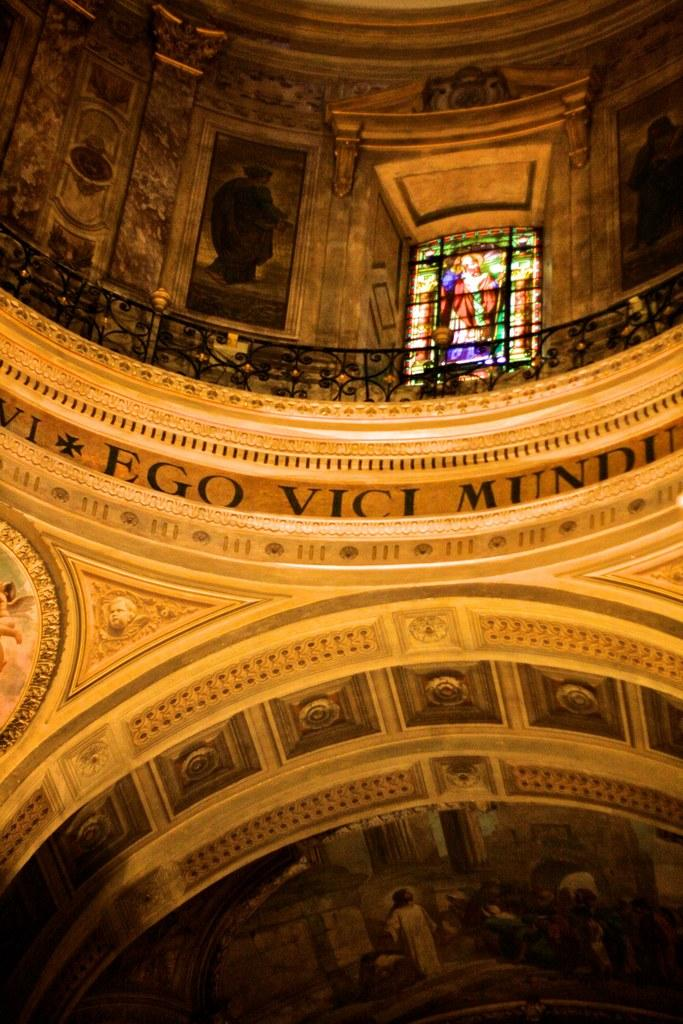What type of structure is visible in the image? There is a building in the image. What can be seen on the wall inside the building? There are many pictures on the wall in the image. Is there any source of natural light visible in the image? Yes, there is a window in the front of the image. What else is present on the wall besides the pictures? There is text on the wall in the image. How many boats are docked at the harbor in the image? There is no harbor or boats present in the image; it features a building with pictures on the wall, a window, and text. 